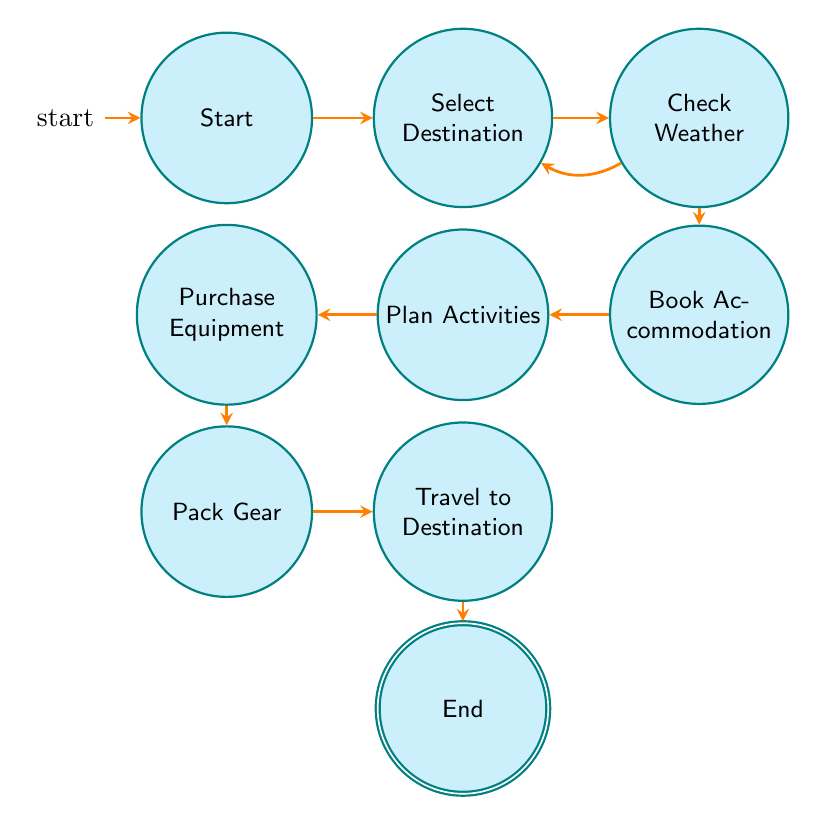What is the initial state in the diagram? The diagram starts with the state labeled "Start," which is indicated as the initial node from where the planning process begins.
Answer: Start How many transitions are from the "Check Weather" state? The "Check Weather" state has two possible transitions: one to "Book Accommodation" and another that loops back to "Select Destination." Therefore, it has two transitions.
Answer: 2 What are the actions associated with the "Select Destination" state? The "Select Destination" state has the action "ResearchSurfSpots" defined, indicating the task to look up popular surf spots.
Answer: ResearchSurfSpots Which state comes after "Pack Gear"? The state that follows "Pack Gear" in the sequence of transitions is "Travel to Destination," according to the directed edges from the "Pack Gear" node.
Answer: Travel to Destination If you are in the "Book Accommodation" state, what is the next state you would transition to? After "Book Accommodation," the next state you transition to is "Plan Activities," as indicated by the directed edge connecting these two nodes.
Answer: Plan Activities What is the last action one would take before the trip is considered complete? The last action before completing the trip planning is "Confirm Bookings," which falls under the "End" state, denoting final checks before departure.
Answer: Confirm Bookings What is the only state that leads directly to the "End" state? The only state leading directly to the "End" state is "Travel to Destination," as depicted by the directed edge connecting these two states.
Answer: Travel to Destination Which state has the most actions defined? The "Plan Activities" state has two actions defined: "CreateItinerary" and "BookTours," making it the state with the most actions in the diagram.
Answer: Plan Activities What happens if the weather conditions are not favorable while in the "Check Weather" state? If the weather conditions are not favorable, you can transition back to "Select Destination" for further research on alternative surf spots. This indicates a loopback option in the state transitions.
Answer: Select Destination 